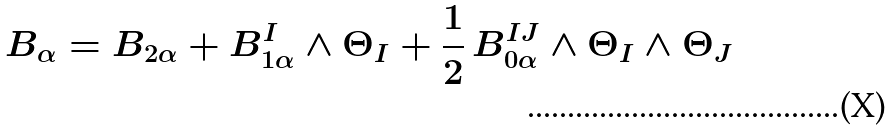Convert formula to latex. <formula><loc_0><loc_0><loc_500><loc_500>B _ { \alpha } = B _ { 2 \alpha } + B _ { 1 \alpha } ^ { I } \wedge \Theta _ { I } + \frac { 1 } { 2 } \, B _ { 0 \alpha } ^ { I J } \wedge \Theta _ { I } \wedge \Theta _ { J }</formula> 